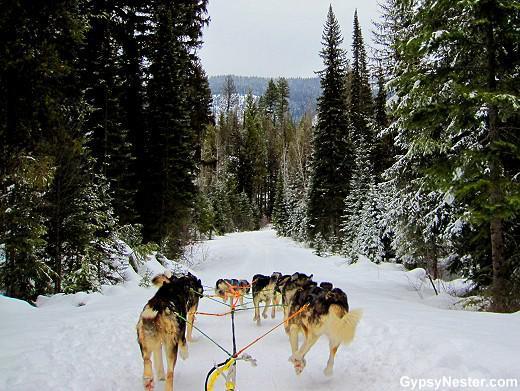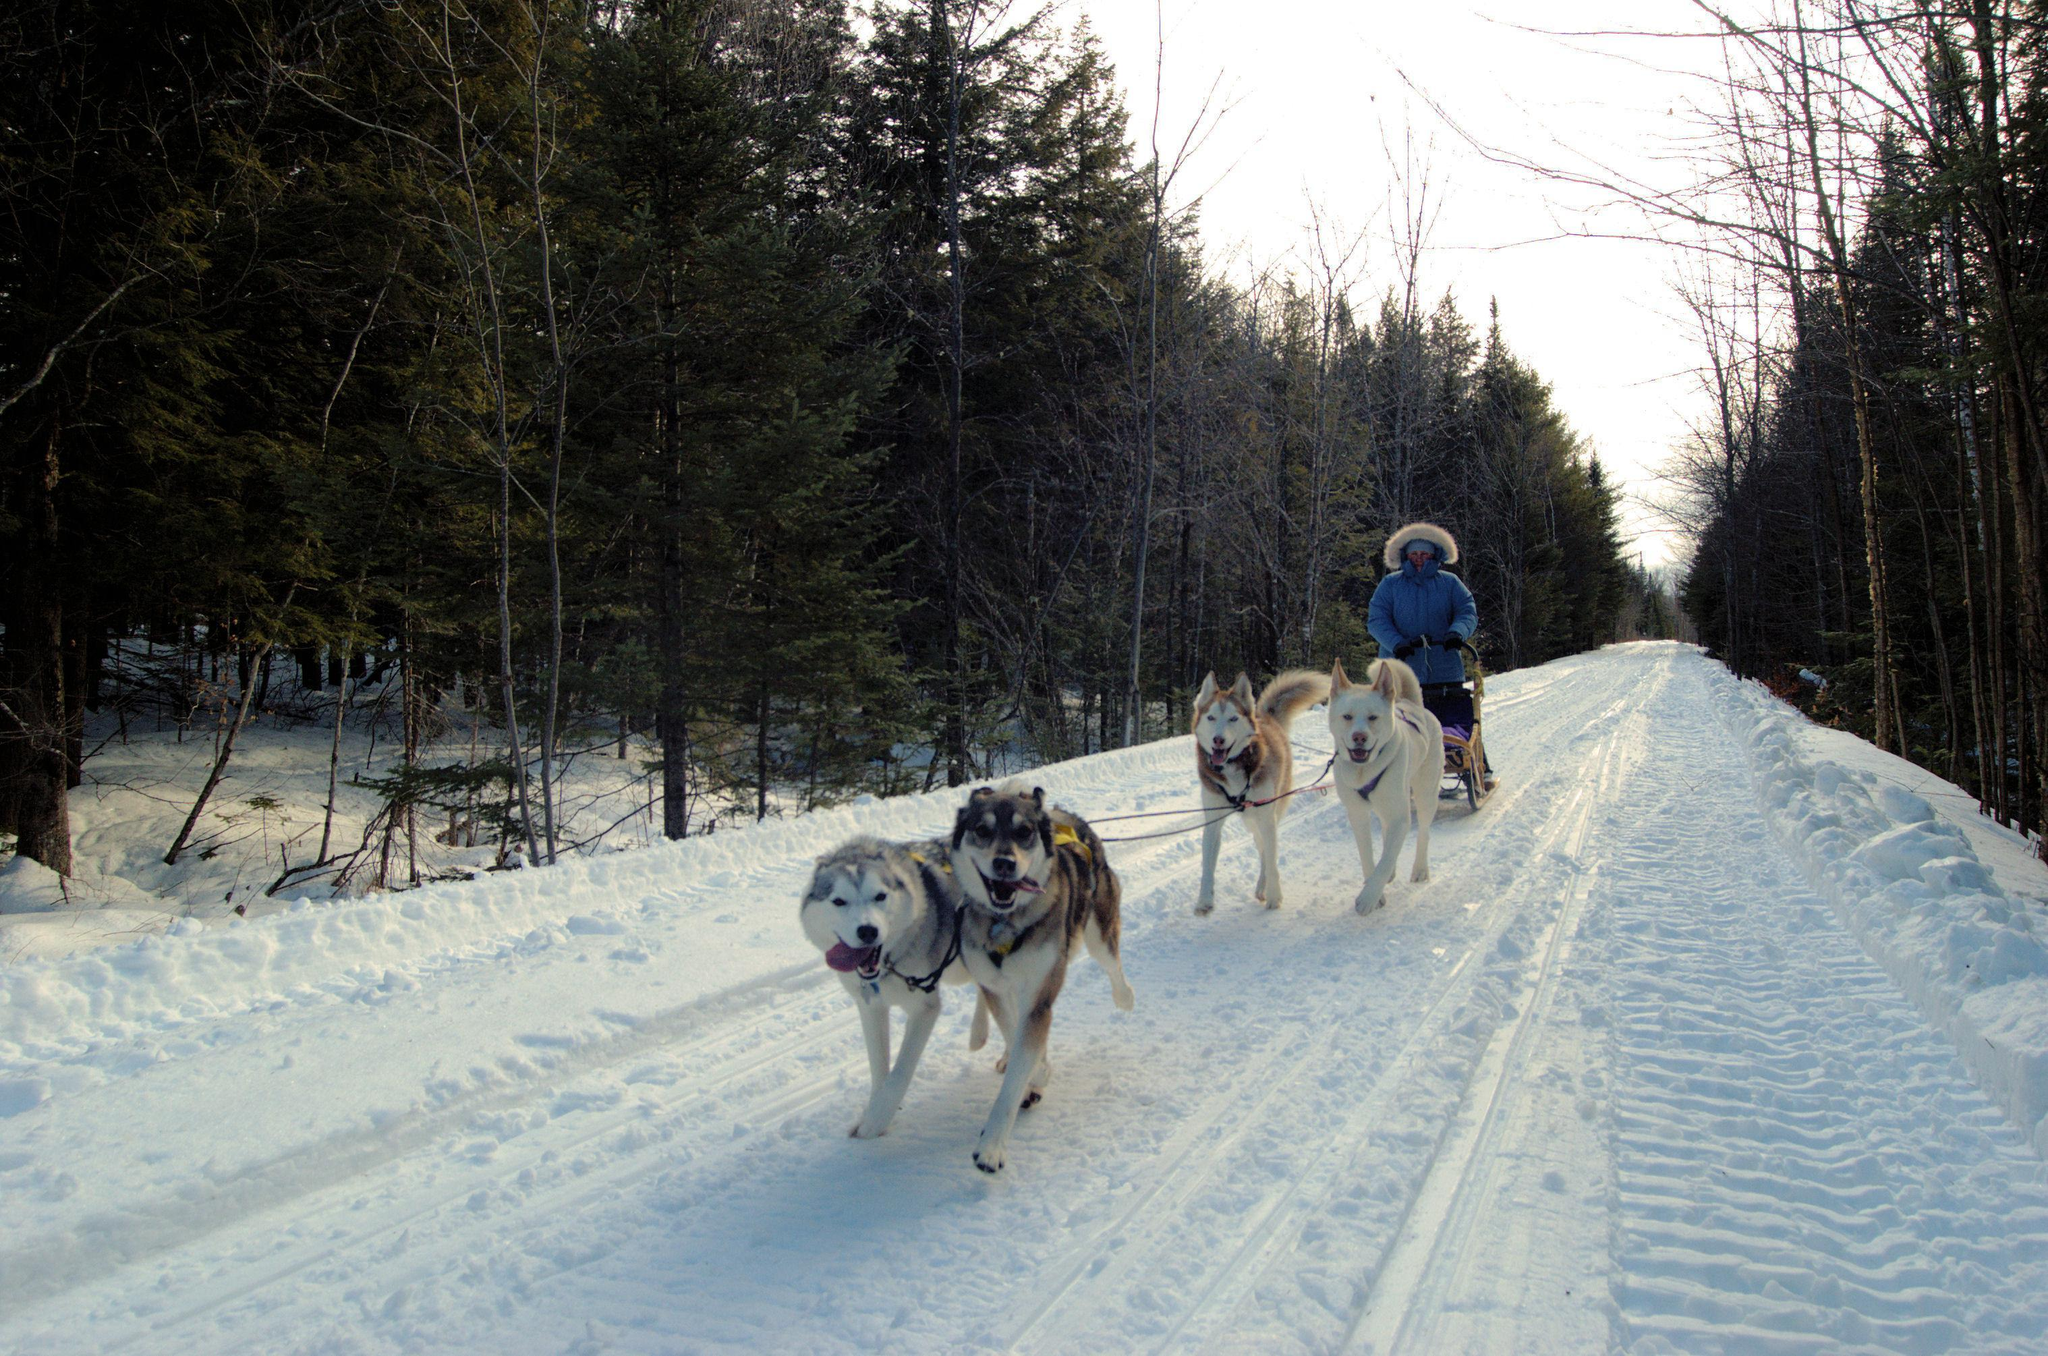The first image is the image on the left, the second image is the image on the right. Evaluate the accuracy of this statement regarding the images: "There are four people with their arms and legs spread to help the sled dogs run on the path.". Is it true? Answer yes or no. No. The first image is the image on the left, the second image is the image on the right. Examine the images to the left and right. Is the description "Two people with outspread arms and spread legs are standing on the left as a sled dog team is coming down the trail." accurate? Answer yes or no. No. 